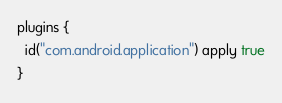Convert code to text. <code><loc_0><loc_0><loc_500><loc_500><_Kotlin_>plugins {
  id("com.android.application") apply true
}
</code> 